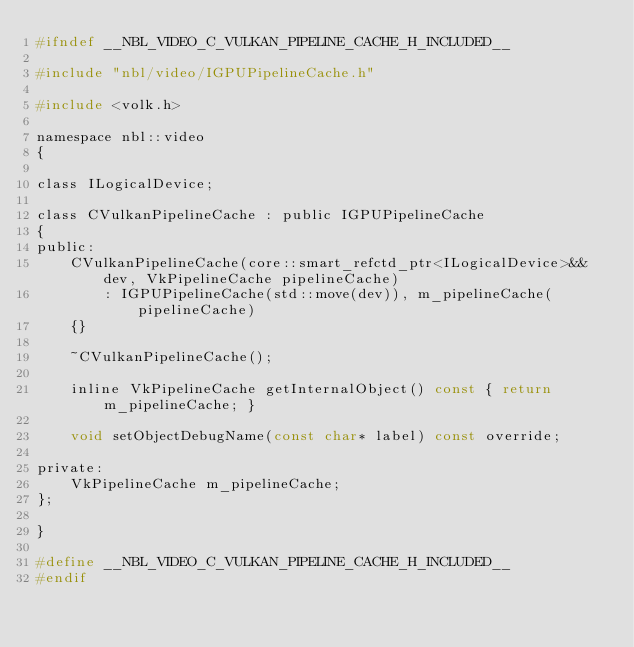Convert code to text. <code><loc_0><loc_0><loc_500><loc_500><_C_>#ifndef __NBL_VIDEO_C_VULKAN_PIPELINE_CACHE_H_INCLUDED__

#include "nbl/video/IGPUPipelineCache.h"

#include <volk.h>

namespace nbl::video
{

class ILogicalDevice;

class CVulkanPipelineCache : public IGPUPipelineCache
{
public:
    CVulkanPipelineCache(core::smart_refctd_ptr<ILogicalDevice>&& dev, VkPipelineCache pipelineCache)
        : IGPUPipelineCache(std::move(dev)), m_pipelineCache(pipelineCache)
    {}

    ~CVulkanPipelineCache();

    inline VkPipelineCache getInternalObject() const { return m_pipelineCache; }

    void setObjectDebugName(const char* label) const override;

private:
    VkPipelineCache m_pipelineCache;
};

}

#define __NBL_VIDEO_C_VULKAN_PIPELINE_CACHE_H_INCLUDED__
#endif
</code> 